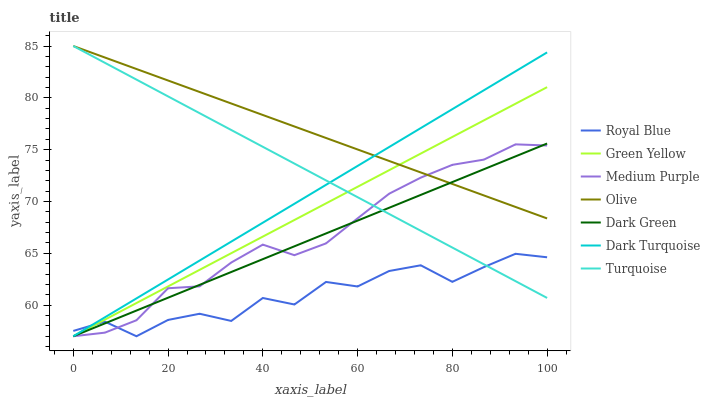Does Royal Blue have the minimum area under the curve?
Answer yes or no. Yes. Does Olive have the maximum area under the curve?
Answer yes or no. Yes. Does Dark Turquoise have the minimum area under the curve?
Answer yes or no. No. Does Dark Turquoise have the maximum area under the curve?
Answer yes or no. No. Is Dark Turquoise the smoothest?
Answer yes or no. Yes. Is Royal Blue the roughest?
Answer yes or no. Yes. Is Medium Purple the smoothest?
Answer yes or no. No. Is Medium Purple the roughest?
Answer yes or no. No. Does Olive have the lowest value?
Answer yes or no. No. Does Olive have the highest value?
Answer yes or no. Yes. Does Dark Turquoise have the highest value?
Answer yes or no. No. Is Royal Blue less than Olive?
Answer yes or no. Yes. Is Olive greater than Royal Blue?
Answer yes or no. Yes. Does Dark Green intersect Green Yellow?
Answer yes or no. Yes. Is Dark Green less than Green Yellow?
Answer yes or no. No. Is Dark Green greater than Green Yellow?
Answer yes or no. No. Does Royal Blue intersect Olive?
Answer yes or no. No. 